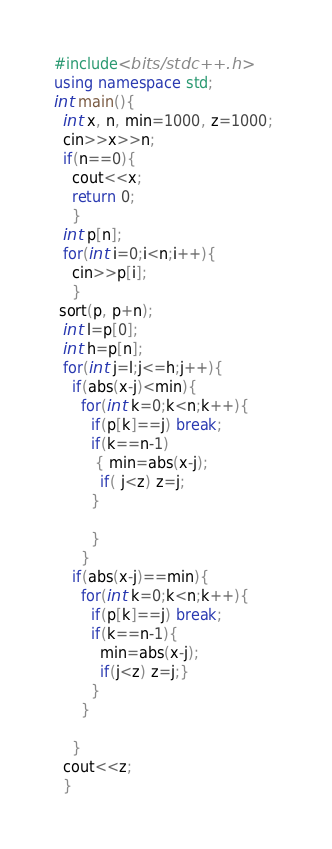<code> <loc_0><loc_0><loc_500><loc_500><_C++_>#include<bits/stdc++.h> 
using namespace std; 
int main(){
  int x, n, min=1000, z=1000; 
  cin>>x>>n; 
  if(n==0){
    cout<<x; 
    return 0;
    }
  int p[n]; 
  for(int i=0;i<n;i++){
    cin>>p[i];
    }
 sort(p, p+n);
  int l=p[0]; 
  int h=p[n]; 
  for(int j=l;j<=h;j++){
    if(abs(x-j)<min){
      for(int k=0;k<n;k++){
        if(p[k]==j) break; 
        if(k==n-1)
         { min=abs(x-j); 
          if( j<z) z=j; 
        }
          
        }
      }
    if(abs(x-j)==min){
      for(int k=0;k<n;k++){
        if(p[k]==j) break; 
        if(k==n-1){
          min=abs(x-j);
          if(j<z) z=j;}
        }
      }
    
    }
  cout<<z; 
  }
</code> 